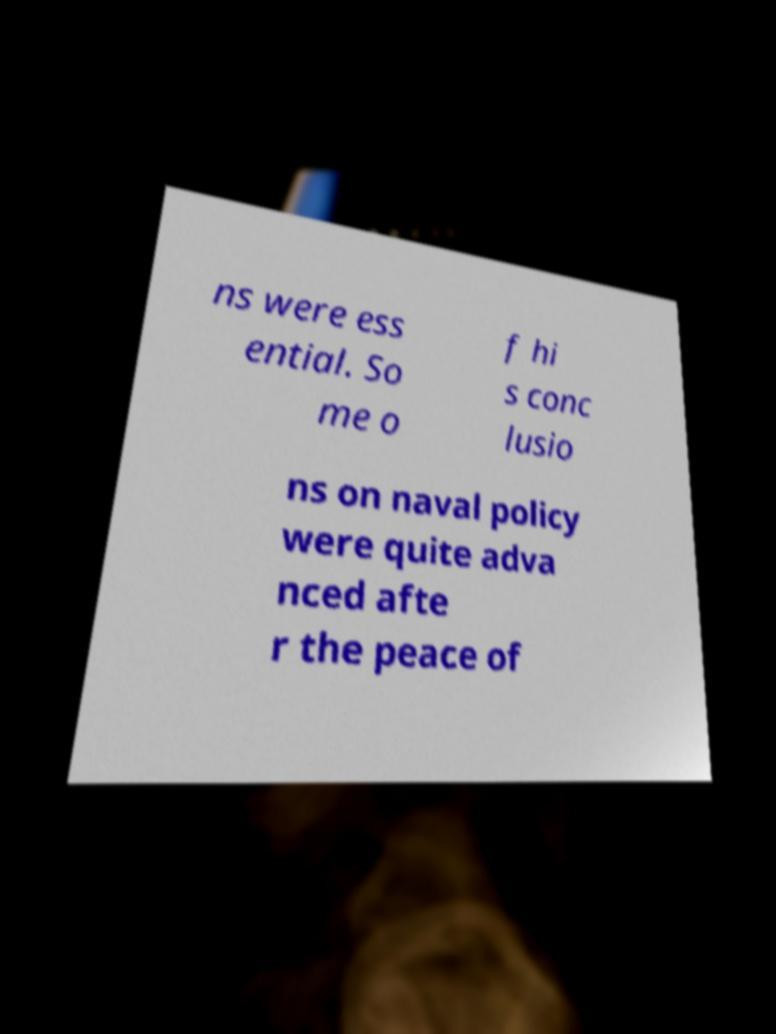I need the written content from this picture converted into text. Can you do that? ns were ess ential. So me o f hi s conc lusio ns on naval policy were quite adva nced afte r the peace of 